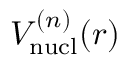Convert formula to latex. <formula><loc_0><loc_0><loc_500><loc_500>V _ { n u c l } ^ { ( n ) } ( r )</formula> 